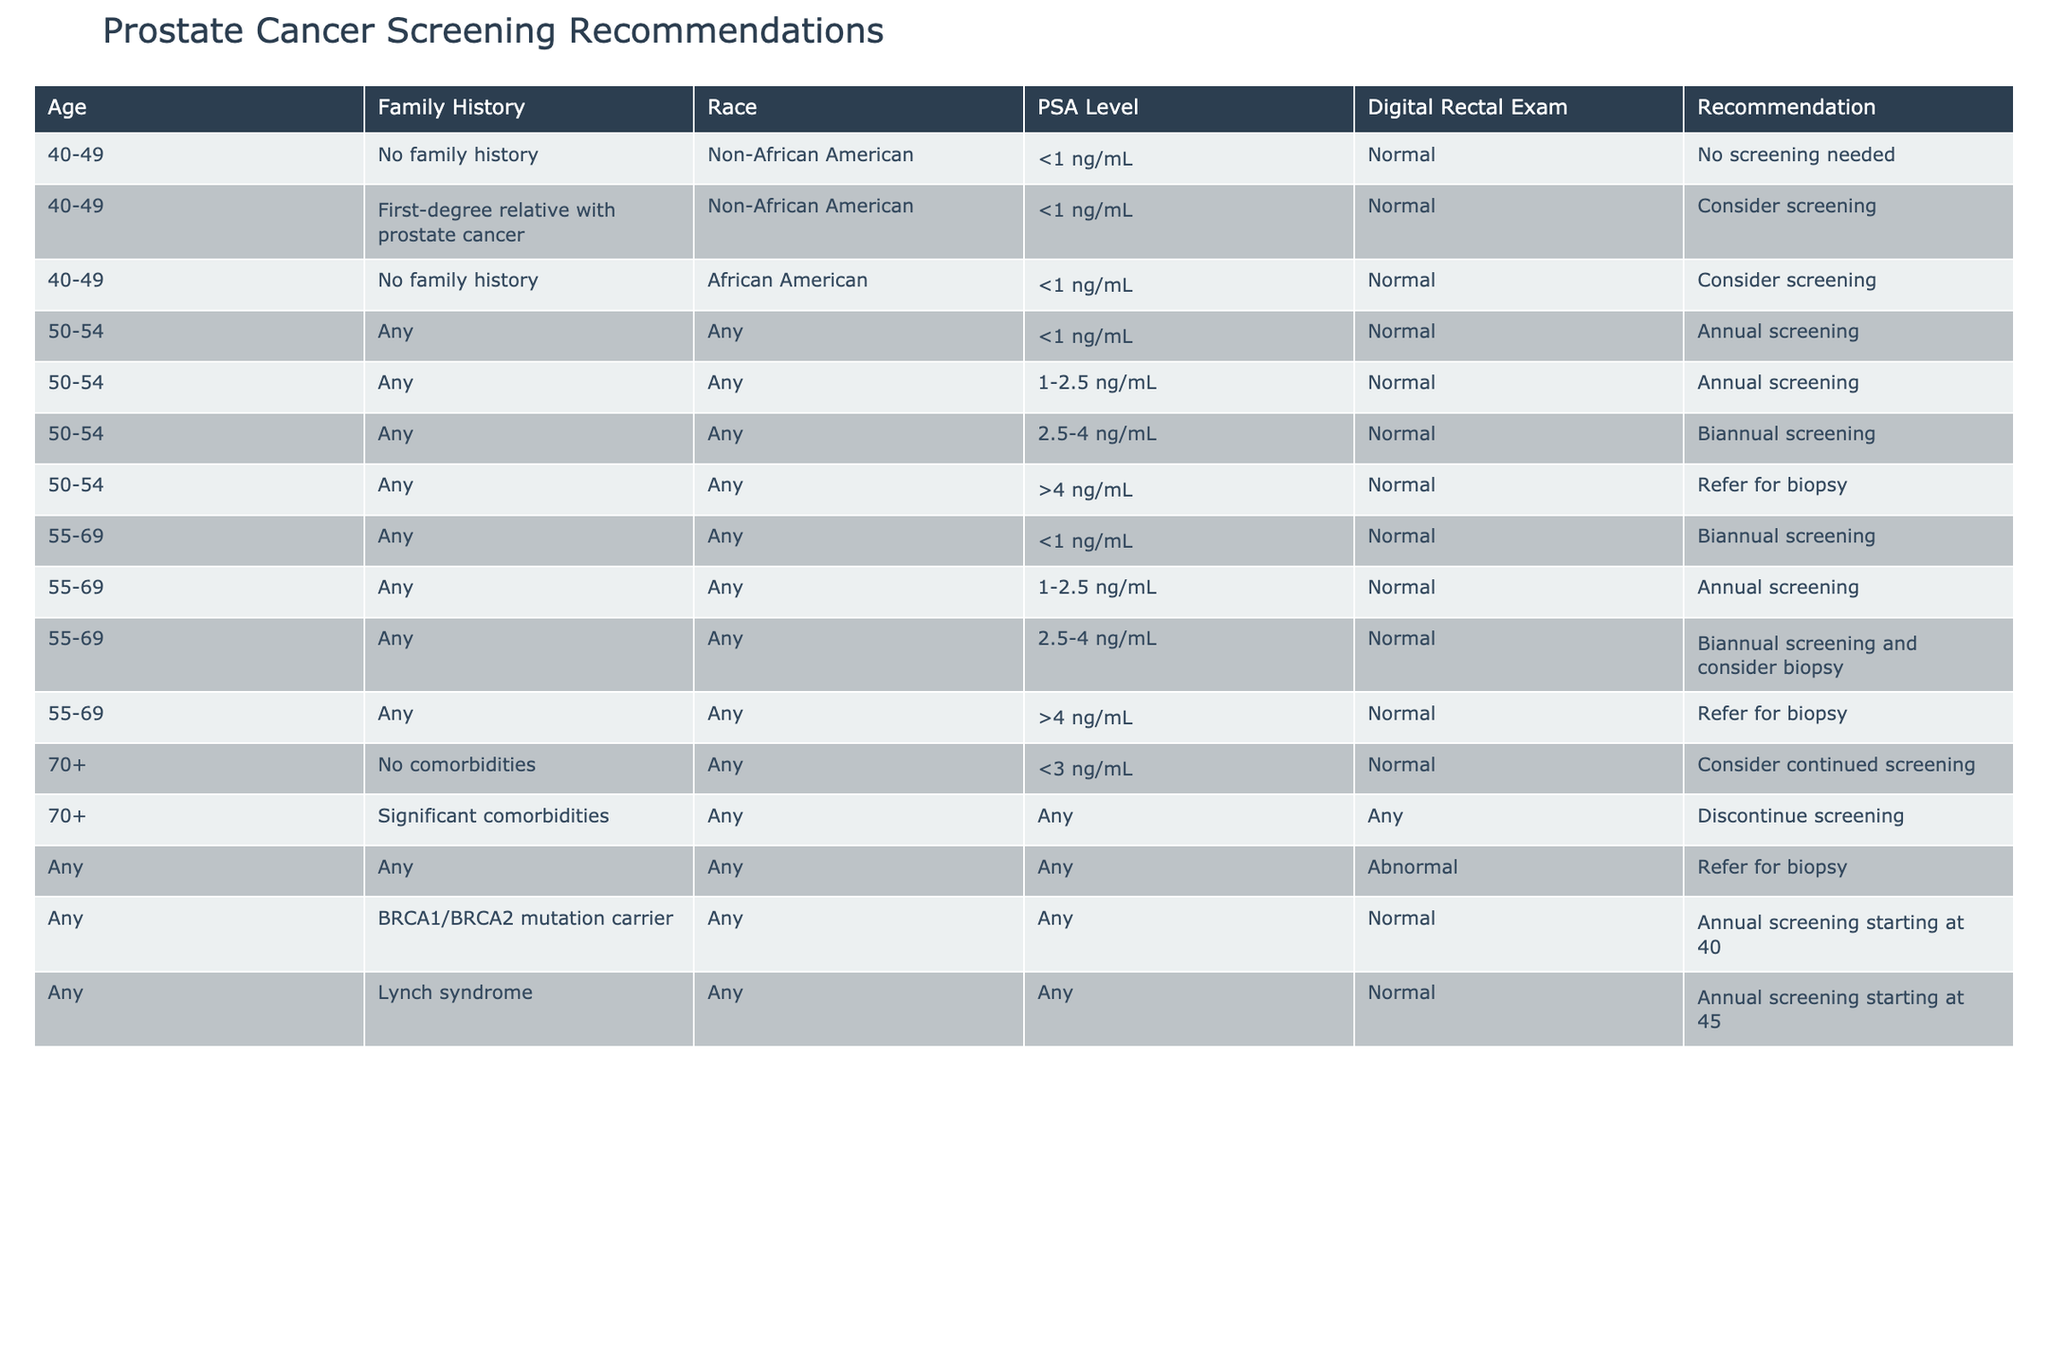What are the screening recommendations for a 45-year-old African American male with no family history? The table shows that for individuals aged 40-49 with no family history and who are African American, the recommendation is to consider screening.
Answer: Consider screening What is the recommendation for a 52-year-old with a PSA level of 3 ng/mL? The table indicates that for individuals aged 50-54 with a PSA level of 2.5-4 ng/mL, the recommendation is biannual screening.
Answer: Biannual screening Is it recommended to discontinue screening for a 72-year-old with significant comorbidities? Yes, the table states that for individuals aged 70+ with significant comorbidities, the recommendation is to discontinue screening.
Answer: Yes How many recommendations for annual screening are listed in the table? The recommendations for annual screening appear for the following cases: individuals aged 50-54 with PSA levels of 1-2.5 ng/mL, individuals aged 55-69 with PSA levels of 1-2.5 ng/mL, BRCA1/BRCA2 mutation carriers starting at age 40, and individuals with Lynch syndrome starting at age 45. This amounts to four instances.
Answer: Four recommendations If a 48-year-old has an abnormal digital rectal exam, what should be the next step according to the table? The table specifies that for any individual with an abnormal digital rectal exam, the recommendation is to refer for biopsy, regardless of age or other factors.
Answer: Refer for biopsy For individuals aged 55-69, what PSA level would trigger a referral for a biopsy? The table indicates that for individuals aged 55-69, if the PSA level is greater than 4 ng/mL, the recommendation is to refer for biopsy.
Answer: Greater than 4 ng/mL What is the difference in recommendations between individuals aged 50-54 with PSA levels of <1 ng/mL and >4 ng/mL? For those aged 50-54 with a PSA level of <1 ng/mL, no screening is needed, while for those with a level of >4 ng/mL, they should be referred for a biopsy. This shows a significant difference in recommendations based on PSA level.
Answer: Significant difference How does the screening recommendation change for a 68-year-old male with a PSA level of 2 ng/mL, compared to a 68-year-old with no documented comorbidities? The table shows that the 68-year-old with a PSA level of 2 ng/mL would be classified under 55-69 years old, and with regards to the PSA level and normal digital rectal exam, the recommendation would be annual screening. In contrast, an age-eligible male with no comorbidities falls into the group of "Consider continued screening." Therefore, the presence of a specific PSA level makes a difference in recommendations.
Answer: Recommendations differ based on PSA level 